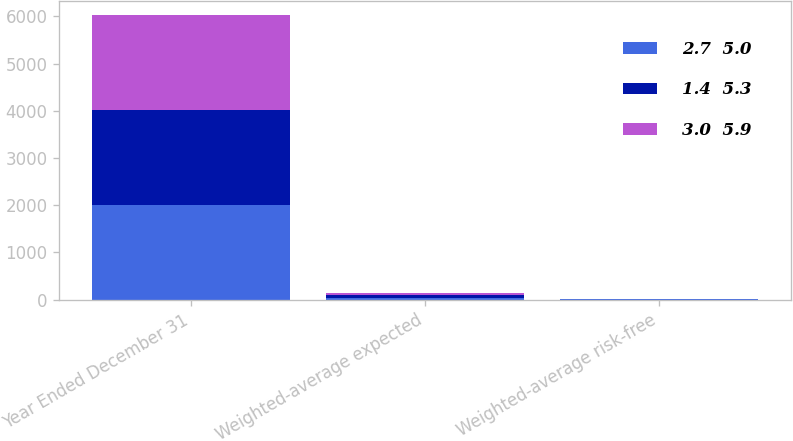Convert chart to OTSL. <chart><loc_0><loc_0><loc_500><loc_500><stacked_bar_chart><ecel><fcel>Year Ended December 31<fcel>Weighted-average expected<fcel>Weighted-average risk-free<nl><fcel>2.7  5.0<fcel>2010<fcel>35<fcel>2.8<nl><fcel>1.4  5.3<fcel>2009<fcel>52<fcel>3<nl><fcel>3.0  5.9<fcel>2008<fcel>44<fcel>3.9<nl></chart> 